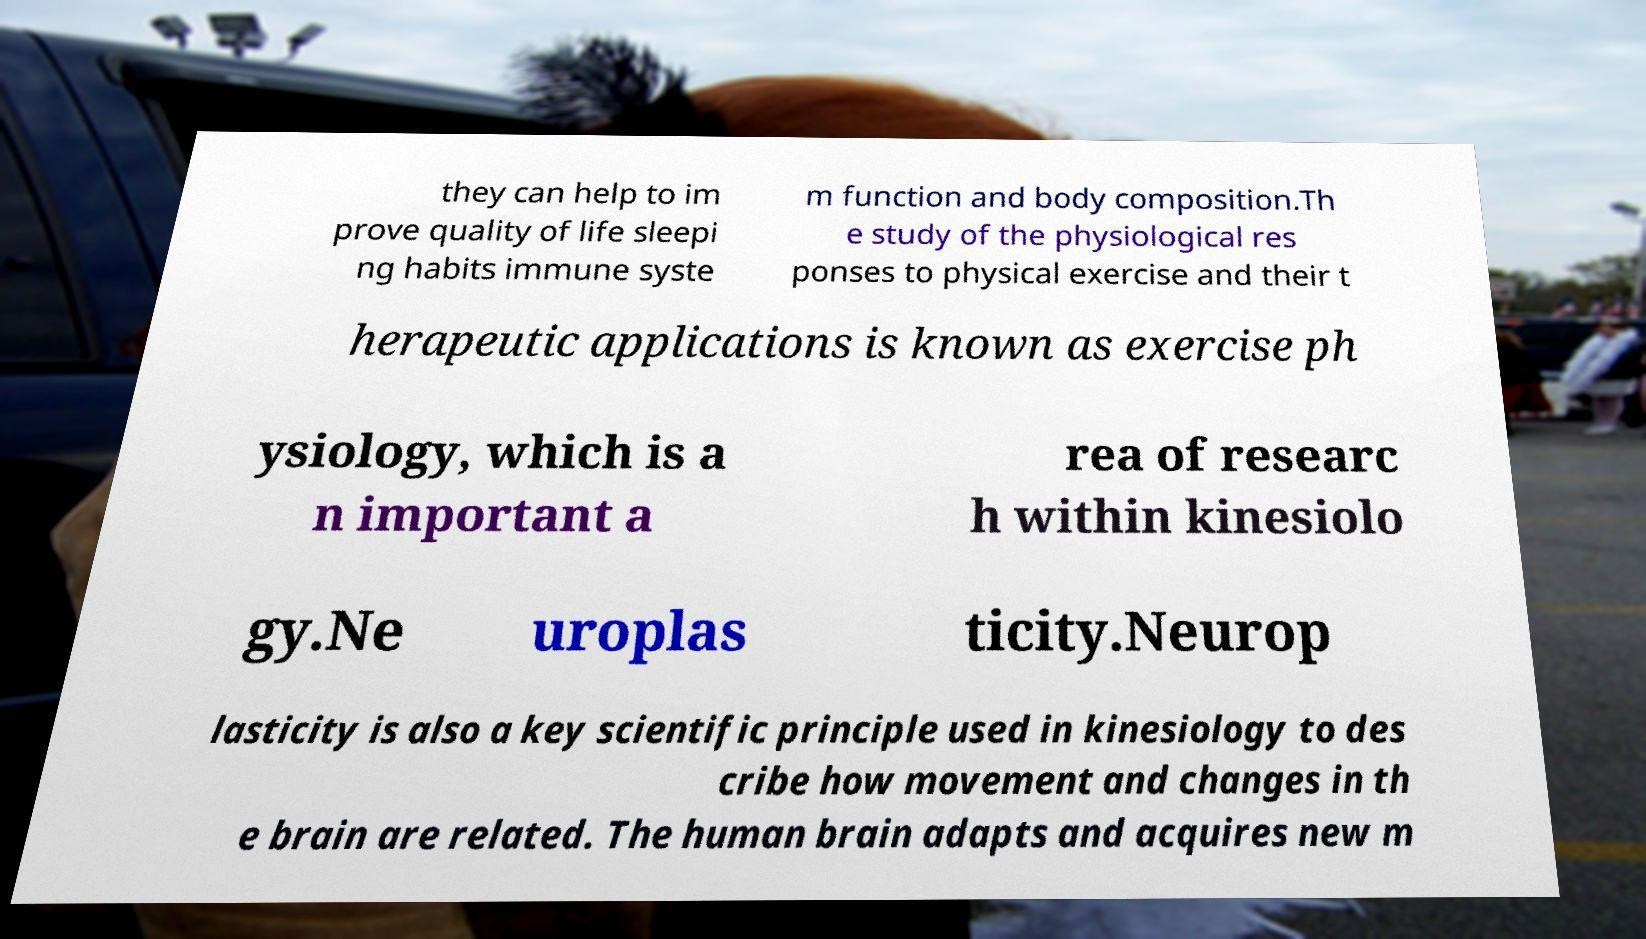For documentation purposes, I need the text within this image transcribed. Could you provide that? they can help to im prove quality of life sleepi ng habits immune syste m function and body composition.Th e study of the physiological res ponses to physical exercise and their t herapeutic applications is known as exercise ph ysiology, which is a n important a rea of researc h within kinesiolo gy.Ne uroplas ticity.Neurop lasticity is also a key scientific principle used in kinesiology to des cribe how movement and changes in th e brain are related. The human brain adapts and acquires new m 